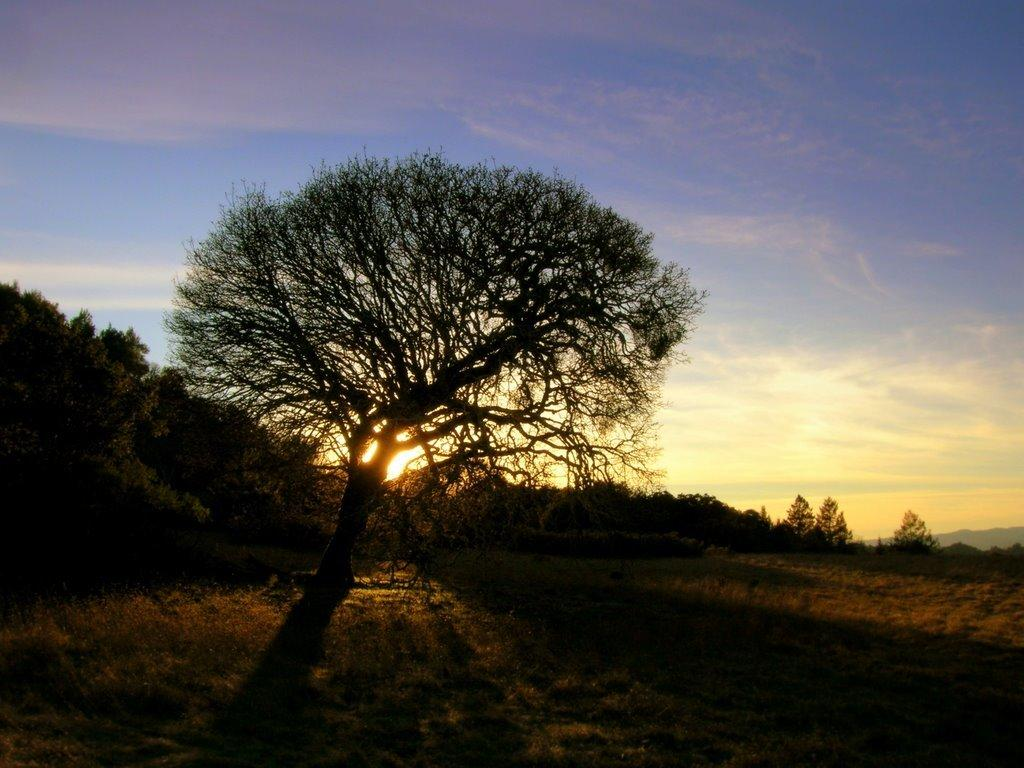What is located on the left side of the image? There is a tree on the left side of the image. What is the position of the tree in relation to the ground? The tree is on the ground. What type of vegetation is present on the ground? There is grass on the ground. What can be seen in the background of the image? There are trees and mountains in the background of the image. What is visible in the sky? Clouds and the sun are visible in the sky. What type of advertisement can be seen on the list near the gate in the image? There is no advertisement, list, or gate present in the image. 